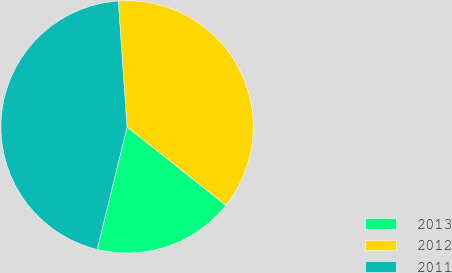Convert chart to OTSL. <chart><loc_0><loc_0><loc_500><loc_500><pie_chart><fcel>2013<fcel>2012<fcel>2011<nl><fcel>18.13%<fcel>36.79%<fcel>45.08%<nl></chart> 